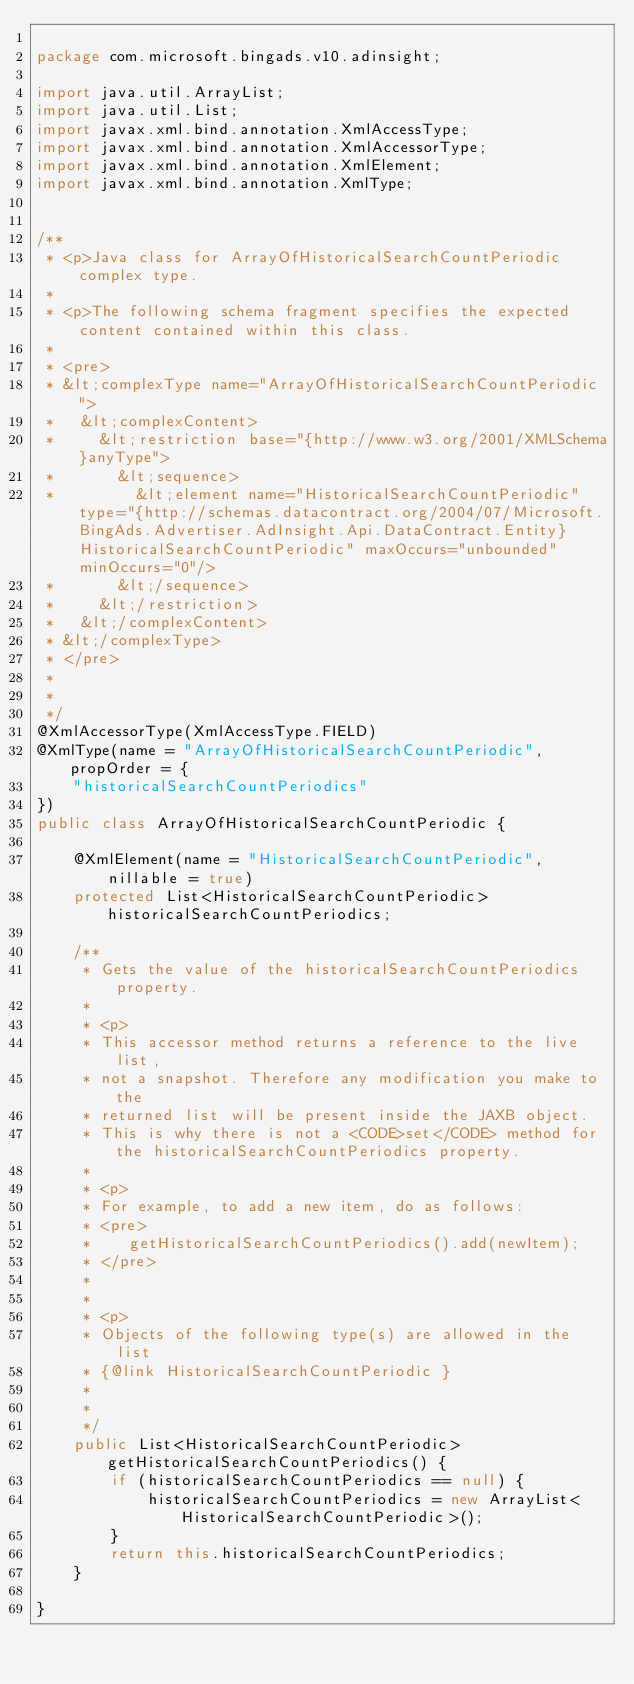Convert code to text. <code><loc_0><loc_0><loc_500><loc_500><_Java_>
package com.microsoft.bingads.v10.adinsight;

import java.util.ArrayList;
import java.util.List;
import javax.xml.bind.annotation.XmlAccessType;
import javax.xml.bind.annotation.XmlAccessorType;
import javax.xml.bind.annotation.XmlElement;
import javax.xml.bind.annotation.XmlType;


/**
 * <p>Java class for ArrayOfHistoricalSearchCountPeriodic complex type.
 * 
 * <p>The following schema fragment specifies the expected content contained within this class.
 * 
 * <pre>
 * &lt;complexType name="ArrayOfHistoricalSearchCountPeriodic">
 *   &lt;complexContent>
 *     &lt;restriction base="{http://www.w3.org/2001/XMLSchema}anyType">
 *       &lt;sequence>
 *         &lt;element name="HistoricalSearchCountPeriodic" type="{http://schemas.datacontract.org/2004/07/Microsoft.BingAds.Advertiser.AdInsight.Api.DataContract.Entity}HistoricalSearchCountPeriodic" maxOccurs="unbounded" minOccurs="0"/>
 *       &lt;/sequence>
 *     &lt;/restriction>
 *   &lt;/complexContent>
 * &lt;/complexType>
 * </pre>
 * 
 * 
 */
@XmlAccessorType(XmlAccessType.FIELD)
@XmlType(name = "ArrayOfHistoricalSearchCountPeriodic", propOrder = {
    "historicalSearchCountPeriodics"
})
public class ArrayOfHistoricalSearchCountPeriodic {

    @XmlElement(name = "HistoricalSearchCountPeriodic", nillable = true)
    protected List<HistoricalSearchCountPeriodic> historicalSearchCountPeriodics;

    /**
     * Gets the value of the historicalSearchCountPeriodics property.
     * 
     * <p>
     * This accessor method returns a reference to the live list,
     * not a snapshot. Therefore any modification you make to the
     * returned list will be present inside the JAXB object.
     * This is why there is not a <CODE>set</CODE> method for the historicalSearchCountPeriodics property.
     * 
     * <p>
     * For example, to add a new item, do as follows:
     * <pre>
     *    getHistoricalSearchCountPeriodics().add(newItem);
     * </pre>
     * 
     * 
     * <p>
     * Objects of the following type(s) are allowed in the list
     * {@link HistoricalSearchCountPeriodic }
     * 
     * 
     */
    public List<HistoricalSearchCountPeriodic> getHistoricalSearchCountPeriodics() {
        if (historicalSearchCountPeriodics == null) {
            historicalSearchCountPeriodics = new ArrayList<HistoricalSearchCountPeriodic>();
        }
        return this.historicalSearchCountPeriodics;
    }

}
</code> 